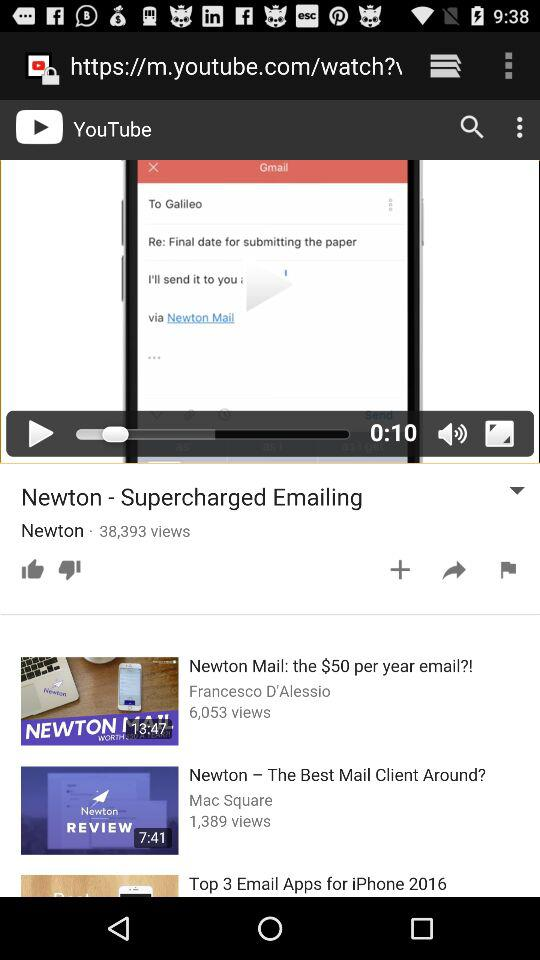What is the duration of the "Newton - Supercharged Emailing" video? The duration of the "Newton - Supercharged Emailing" video is 10 seconds. 